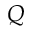<formula> <loc_0><loc_0><loc_500><loc_500>Q</formula> 